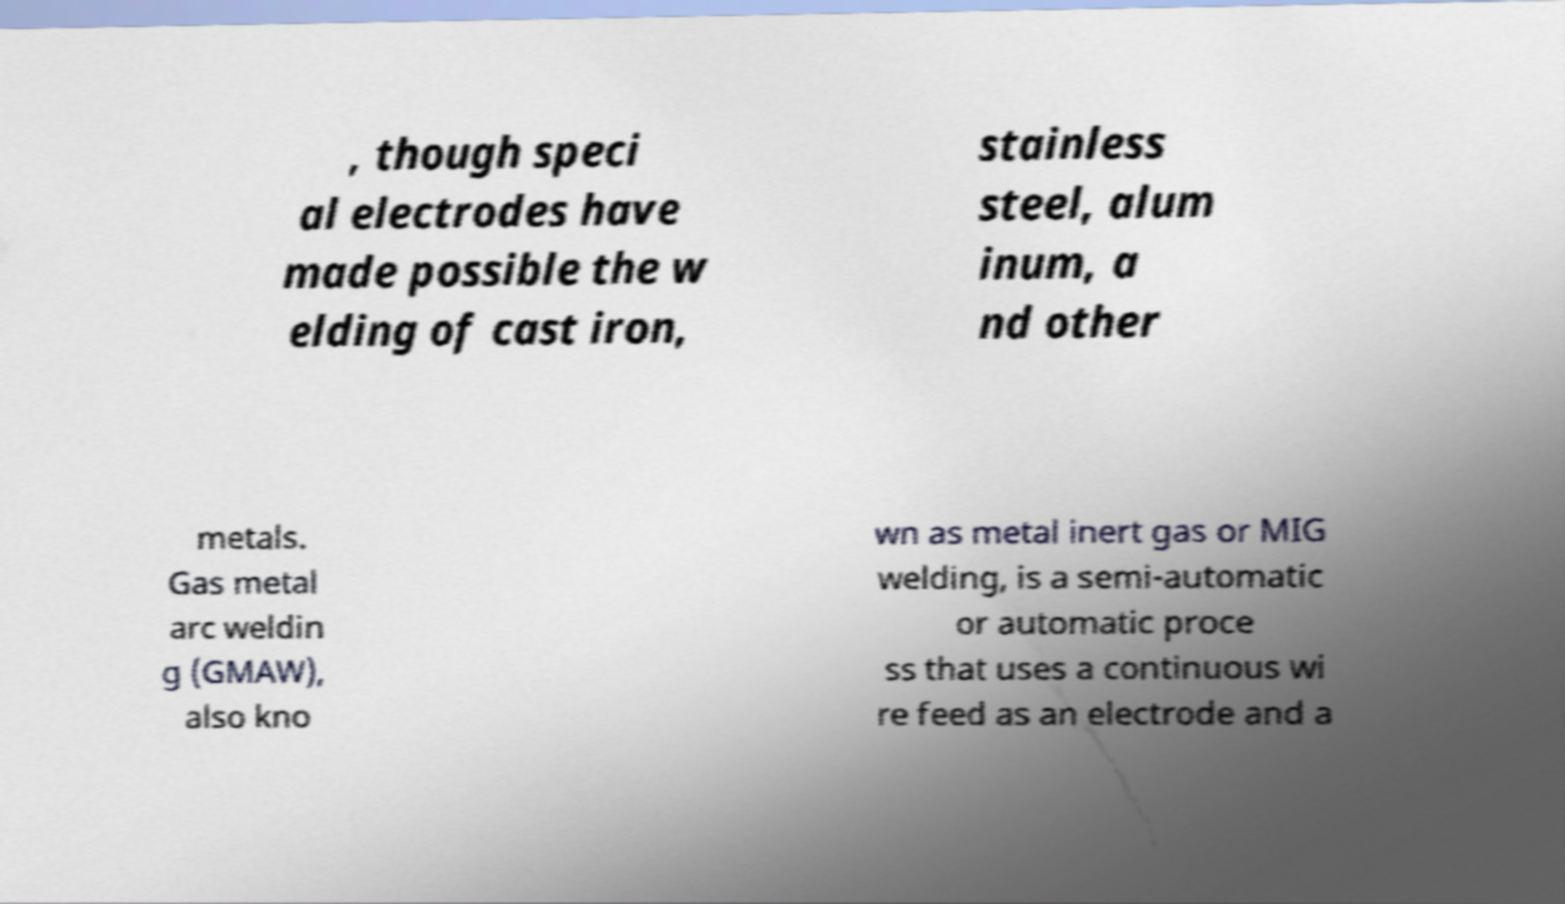For documentation purposes, I need the text within this image transcribed. Could you provide that? , though speci al electrodes have made possible the w elding of cast iron, stainless steel, alum inum, a nd other metals. Gas metal arc weldin g (GMAW), also kno wn as metal inert gas or MIG welding, is a semi-automatic or automatic proce ss that uses a continuous wi re feed as an electrode and a 